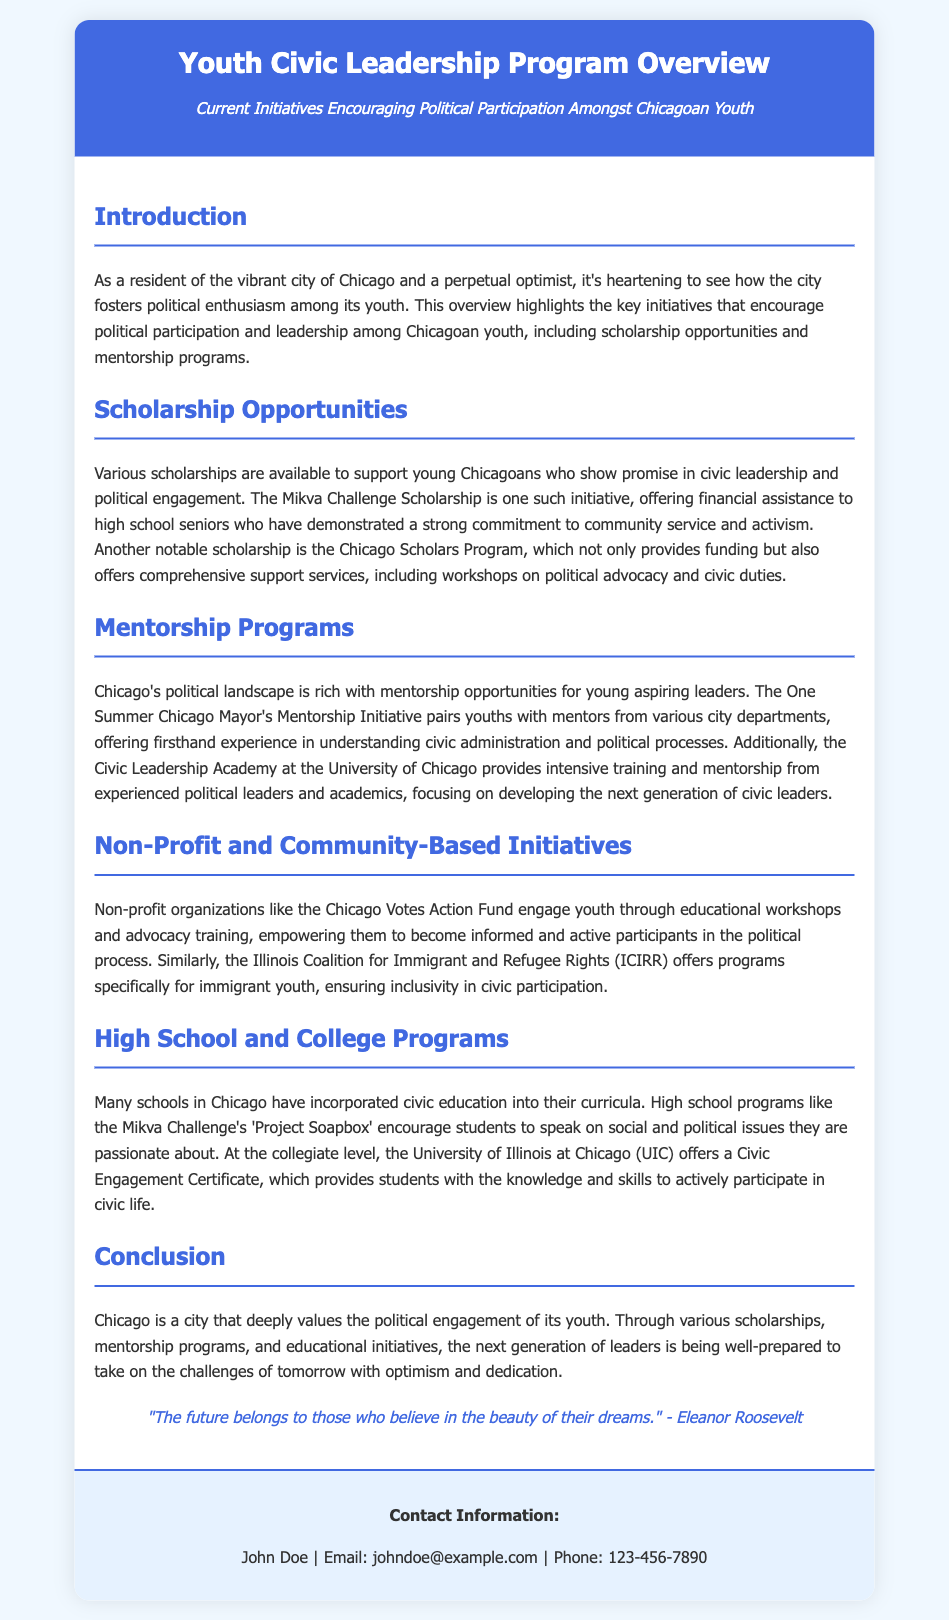What is the name of the scholarship initiative specifically mentioned for high school seniors? The document specifically mentions the Mikva Challenge Scholarship as a scholarship initiative for high school seniors committed to community service and activism.
Answer: Mikva Challenge Scholarship What educational institution offers a Civic Engagement Certificate? According to the document, the University of Illinois at Chicago (UIC) offers a Civic Engagement Certificate.
Answer: University of Illinois at Chicago What type of program is “Project Soapbox”? The document describes "Project Soapbox" as a high school program that encourages students to speak on social and political issues they are passionate about.
Answer: High school program Which initiative pairs youth with mentors from city departments? The One Summer Chicago Mayor's Mentorship Initiative is mentioned as the initiative that pairs youths with mentors from various city departments.
Answer: One Summer Chicago Mayor's Mentorship Initiative What is the underlying theme of the document about Chicago's approach to youth political engagement? The document conveys that Chicago deeply values the political engagement of its youth through various support systems like scholarships and mentorship.
Answer: Deeply values political engagement What organization focuses on engagement for immigrant youth? The Illinois Coalition for Immigrant and Refugee Rights (ICIRR) is highlighted as the organization focusing on programs for immigrant youth.
Answer: ICIRR What is emphasized as crucial for young Chicagoans in the context of civic education? The document emphasizes that many schools in Chicago have incorporated civic education into their curricula as crucial for young Chicagoans.
Answer: Civic education What quote is used to inspire optimism in the document? The document includes a quote from Eleanor Roosevelt to inspire optimism, stating, "The future belongs to those who believe in the beauty of their dreams."
Answer: "The future belongs to those who believe in the beauty of their dreams." 